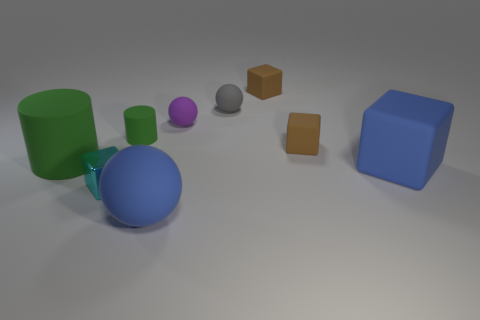Subtract all blue balls. How many balls are left? 2 Subtract all cyan blocks. How many blocks are left? 3 Subtract 1 balls. How many balls are left? 2 Subtract all spheres. How many objects are left? 6 Subtract all cyan blocks. How many purple balls are left? 1 Add 8 tiny metal cubes. How many tiny metal cubes exist? 9 Subtract 0 gray blocks. How many objects are left? 9 Subtract all purple balls. Subtract all cyan blocks. How many balls are left? 2 Subtract all gray balls. Subtract all tiny brown rubber blocks. How many objects are left? 6 Add 5 metallic blocks. How many metallic blocks are left? 6 